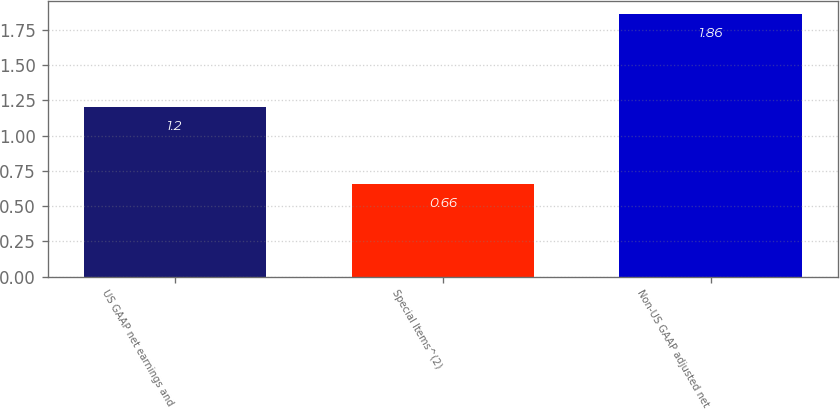Convert chart to OTSL. <chart><loc_0><loc_0><loc_500><loc_500><bar_chart><fcel>US GAAP net earnings and<fcel>Special Items^(2)<fcel>Non-US GAAP adjusted net<nl><fcel>1.2<fcel>0.66<fcel>1.86<nl></chart> 